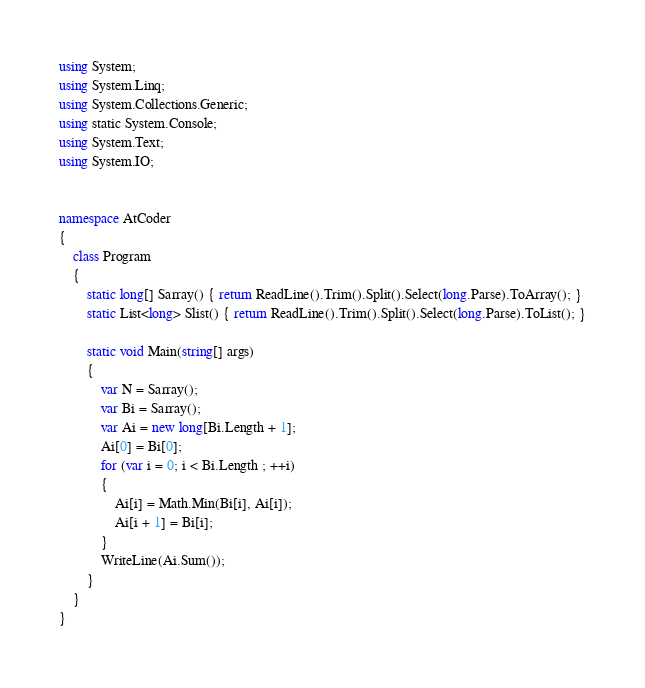<code> <loc_0><loc_0><loc_500><loc_500><_C#_>using System;
using System.Linq;
using System.Collections.Generic;
using static System.Console;
using System.Text;
using System.IO;


namespace AtCoder
{
    class Program
    {
        static long[] Sarray() { return ReadLine().Trim().Split().Select(long.Parse).ToArray(); }
        static List<long> Slist() { return ReadLine().Trim().Split().Select(long.Parse).ToList(); }

        static void Main(string[] args)
        {
            var N = Sarray();
            var Bi = Sarray();
            var Ai = new long[Bi.Length + 1];
            Ai[0] = Bi[0];
            for (var i = 0; i < Bi.Length ; ++i)
            {
                Ai[i] = Math.Min(Bi[i], Ai[i]);
                Ai[i + 1] = Bi[i];
            }
            WriteLine(Ai.Sum());
        }
    }
}
</code> 